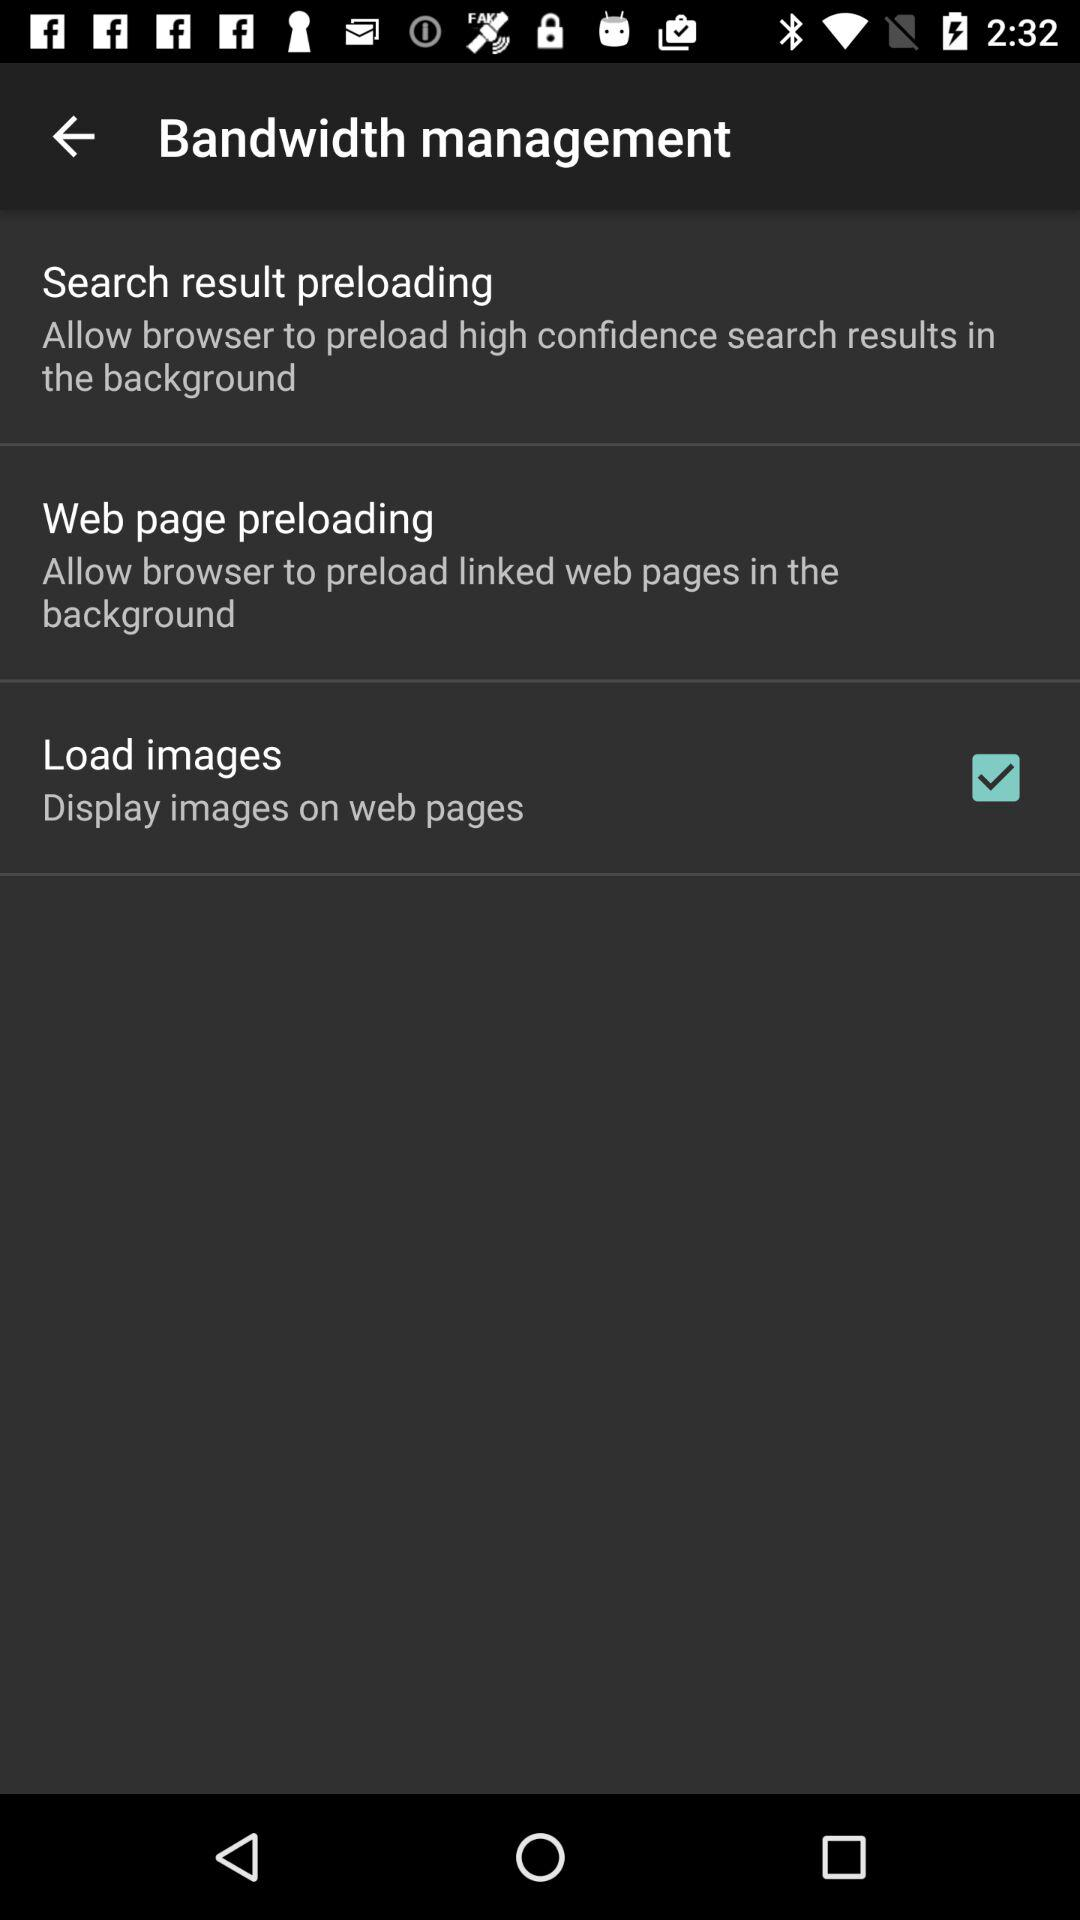What is the status of "Load images"? The status of "Load images" is "on". 